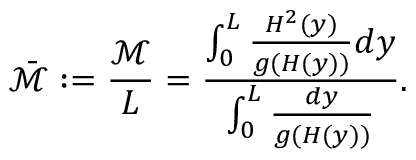<formula> <loc_0><loc_0><loc_500><loc_500>\bar { \mathcal { M } } \colon = \frac { \mathcal { M } } { L } = \frac { \int _ { 0 } ^ { L } { \frac { H ^ { 2 } ( y ) } { g ( H ( y ) ) } d y } } { \int _ { 0 } ^ { L } { \frac { d y } { g ( H ( y ) ) } } } .</formula> 